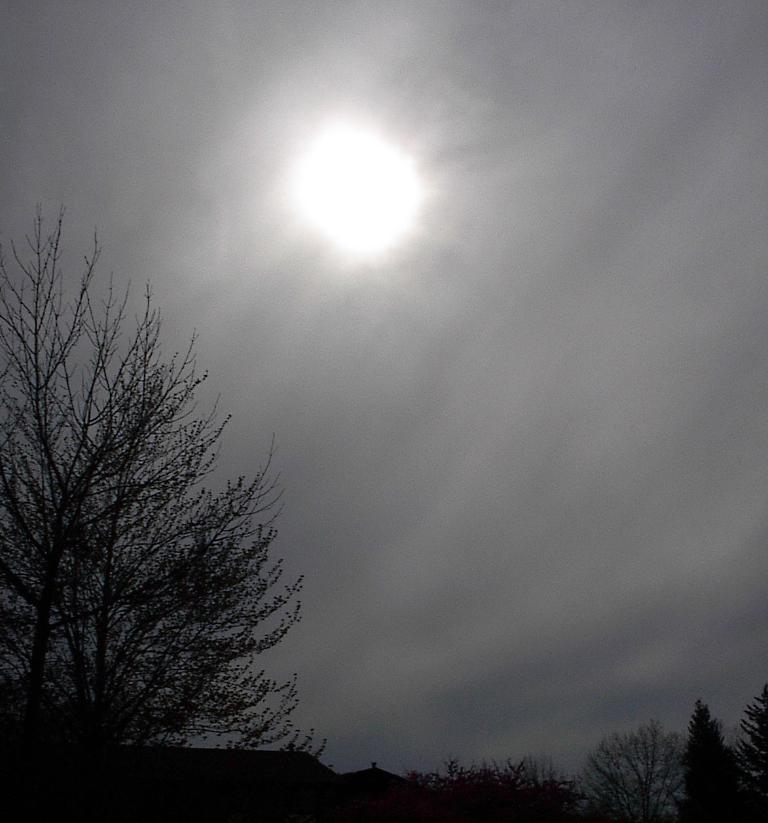What type of vegetation can be seen in the image? There are trees in the image. What is visible in the background of the image? The sky is visible in the background of the image. Can the sun be seen in the image? Yes, the sun is observable in the sky. What type of jewel can be seen hanging from the trees in the image? There is no jewel present in the image; it features trees and a sky with the sun visible. 